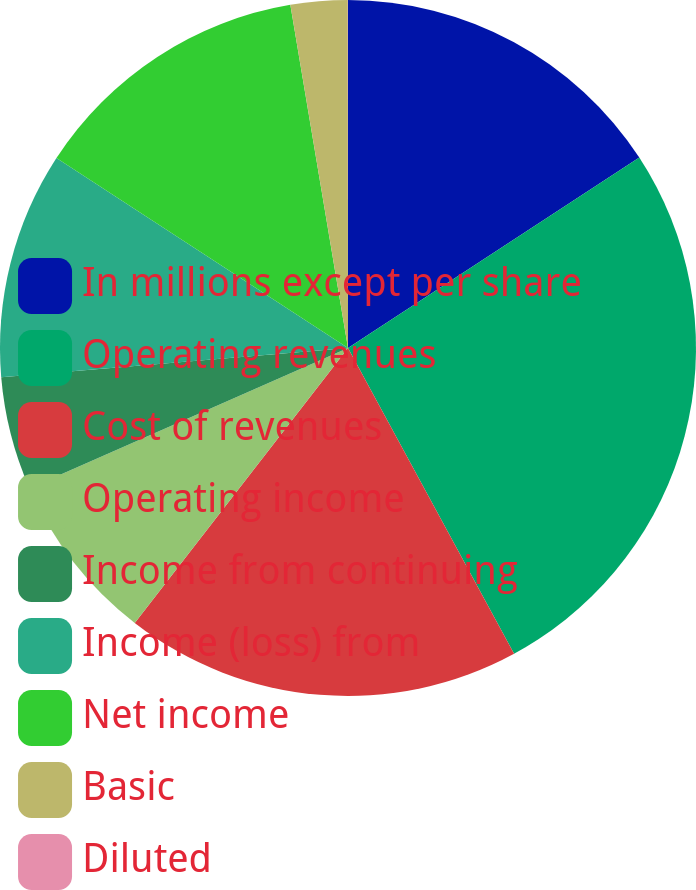<chart> <loc_0><loc_0><loc_500><loc_500><pie_chart><fcel>In millions except per share<fcel>Operating revenues<fcel>Cost of revenues<fcel>Operating income<fcel>Income from continuing<fcel>Income (loss) from<fcel>Net income<fcel>Basic<fcel>Diluted<nl><fcel>15.79%<fcel>26.3%<fcel>18.42%<fcel>7.9%<fcel>5.27%<fcel>10.53%<fcel>13.16%<fcel>2.64%<fcel>0.01%<nl></chart> 